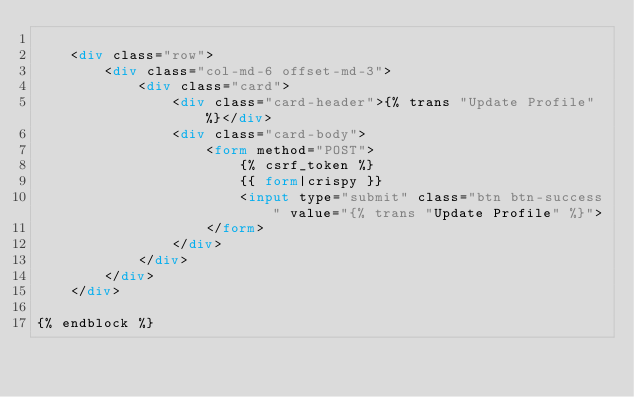Convert code to text. <code><loc_0><loc_0><loc_500><loc_500><_HTML_>
    <div class="row">
        <div class="col-md-6 offset-md-3">
            <div class="card">
                <div class="card-header">{% trans "Update Profile" %}</div>
                <div class="card-body">
                    <form method="POST">
                        {% csrf_token %}
                        {{ form|crispy }}
                        <input type="submit" class="btn btn-success" value="{% trans "Update Profile" %}">
                    </form>
                </div>
            </div>
        </div>
    </div>

{% endblock %}</code> 